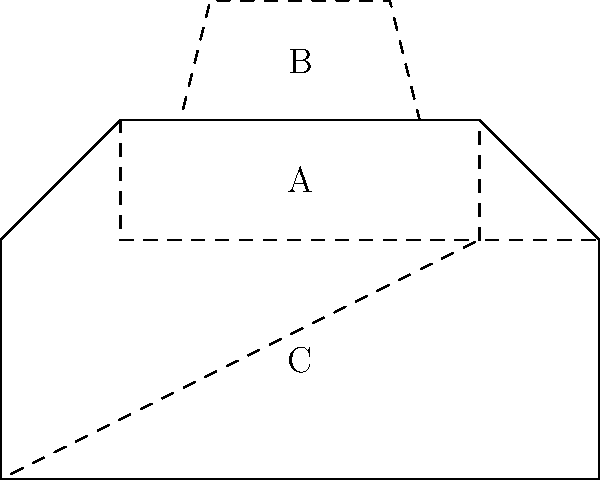In the context of detecting and segmenting different parts of a car exterior from 2D sketches, which machine learning approach would be most suitable for identifying the regions labeled A, B, and C in the given sketch? To answer this question, let's consider the characteristics of the problem and the available machine learning approaches:

1. The task involves identifying and segmenting different parts of a car exterior from a 2D sketch.
2. The regions A, B, and C represent distinct car parts (hood, windshield, and side panel, respectively).
3. We need to classify and localize these parts within the image.

Given these requirements, the most suitable approach would be:

1. Convolutional Neural Networks (CNNs) with semantic segmentation:
   - CNNs are excellent at processing 2D image data and learning spatial hierarchies of features.
   - Semantic segmentation allows for pixel-wise classification, enabling the network to identify and localize different car parts.

2. Specifically, a U-Net or FCN (Fully Convolutional Network) architecture would be ideal:
   - These architectures are designed for precise segmentation tasks.
   - They can maintain spatial information throughout the network, which is crucial for accurately delineating car parts.

3. The network would be trained on a dataset of labeled car sketches:
   - Each pixel in the training images would be labeled with its corresponding car part.
   - The network would learn to associate visual features with specific car parts.

4. During inference, the network would output a segmentation mask:
   - Each pixel in the output would be classified as belonging to a specific car part (hood, windshield, side panel, etc.).
   - This would effectively segment the regions A, B, and C in the given sketch.

5. Post-processing techniques like conditional random fields (CRFs) could be applied to refine the segmentation boundaries.

This approach would allow for accurate detection and segmentation of different car parts from 2D sketches, which is essential for the design process of Acura vehicle exteriors.
Answer: Convolutional Neural Network with semantic segmentation (e.g., U-Net or FCN) 